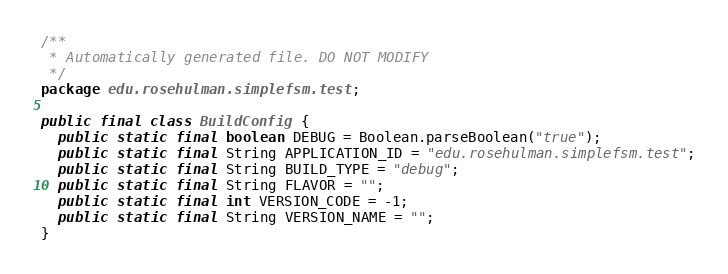Convert code to text. <code><loc_0><loc_0><loc_500><loc_500><_Java_>/**
 * Automatically generated file. DO NOT MODIFY
 */
package edu.rosehulman.simplefsm.test;

public final class BuildConfig {
  public static final boolean DEBUG = Boolean.parseBoolean("true");
  public static final String APPLICATION_ID = "edu.rosehulman.simplefsm.test";
  public static final String BUILD_TYPE = "debug";
  public static final String FLAVOR = "";
  public static final int VERSION_CODE = -1;
  public static final String VERSION_NAME = "";
}
</code> 